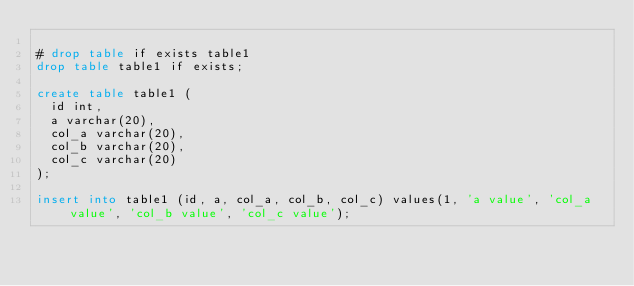<code> <loc_0><loc_0><loc_500><loc_500><_SQL_>
# drop table if exists table1
drop table table1 if exists;

create table table1 (
  id int,
  a varchar(20),
  col_a varchar(20),
  col_b varchar(20),
  col_c varchar(20)
);

insert into table1 (id, a, col_a, col_b, col_c) values(1, 'a value', 'col_a value', 'col_b value', 'col_c value');
</code> 